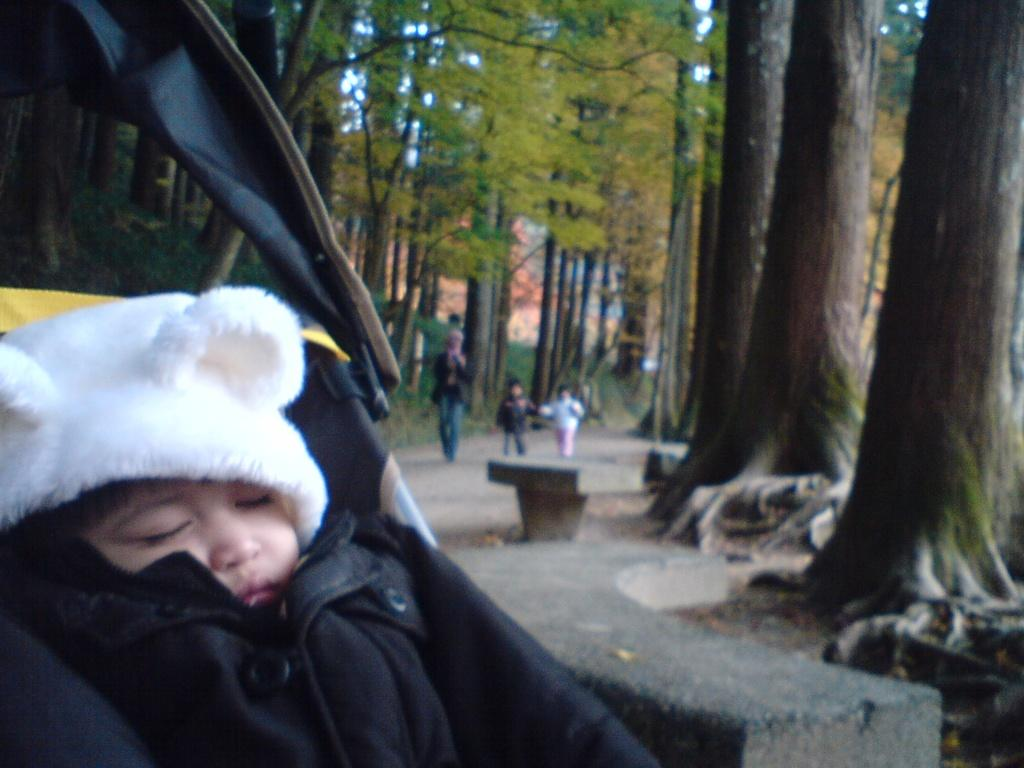What is the main subject of the image? There is a baby sleeping in the image. What can be seen in the background of the image? There are trees visible in the image. What are the people in the image doing? There is a group of persons walking on the ground in the image. What type of seating is present in the image? There is a bench in the image. What is visible above the trees and people in the image? The sky is visible in the image. What type of island can be seen in the image? There is no island present in the image. What event is taking place in the image that led to the baby's birth? The image does not depict any event related to the baby's birth; it simply shows the baby sleeping. 